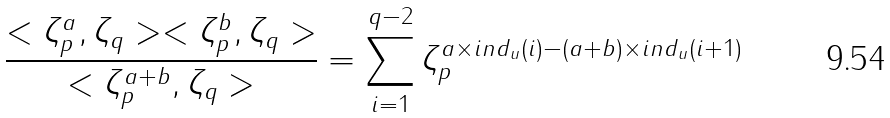<formula> <loc_0><loc_0><loc_500><loc_500>\frac { < \zeta _ { p } ^ { a } , \zeta _ { q } > < \zeta _ { p } ^ { b } , \zeta _ { q } > } { < \zeta _ { p } ^ { a + b } , \zeta _ { q } > } = \sum _ { i = 1 } ^ { q - 2 } \zeta _ { p } ^ { a \times i n d _ { u } ( i ) - ( a + b ) \times i n d _ { u } ( i + 1 ) }</formula> 